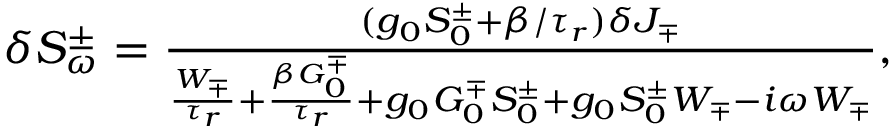Convert formula to latex. <formula><loc_0><loc_0><loc_500><loc_500>\begin{array} { r } { \delta S _ { \omega } ^ { \pm } = \frac { ( g _ { 0 } S _ { 0 } ^ { \pm } + \beta / \tau _ { r } ) \delta J _ { \mp } } { \frac { W _ { \mp } } { \tau _ { r } } + \frac { \beta G _ { 0 } ^ { \mp } } { \tau _ { r } } + g _ { 0 } G _ { 0 } ^ { \mp } S _ { 0 } ^ { \pm } + g _ { 0 } S _ { 0 } ^ { \pm } W _ { \mp } - i \omega W _ { \mp } } , } \end{array}</formula> 